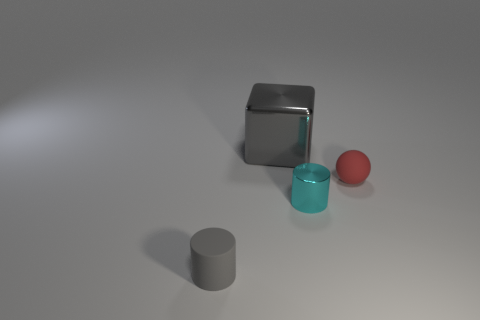Add 3 yellow metallic objects. How many objects exist? 7 Add 1 cyan shiny cylinders. How many cyan shiny cylinders are left? 2 Add 1 small matte objects. How many small matte objects exist? 3 Subtract 1 gray cylinders. How many objects are left? 3 Subtract all small cyan cylinders. Subtract all gray matte things. How many objects are left? 2 